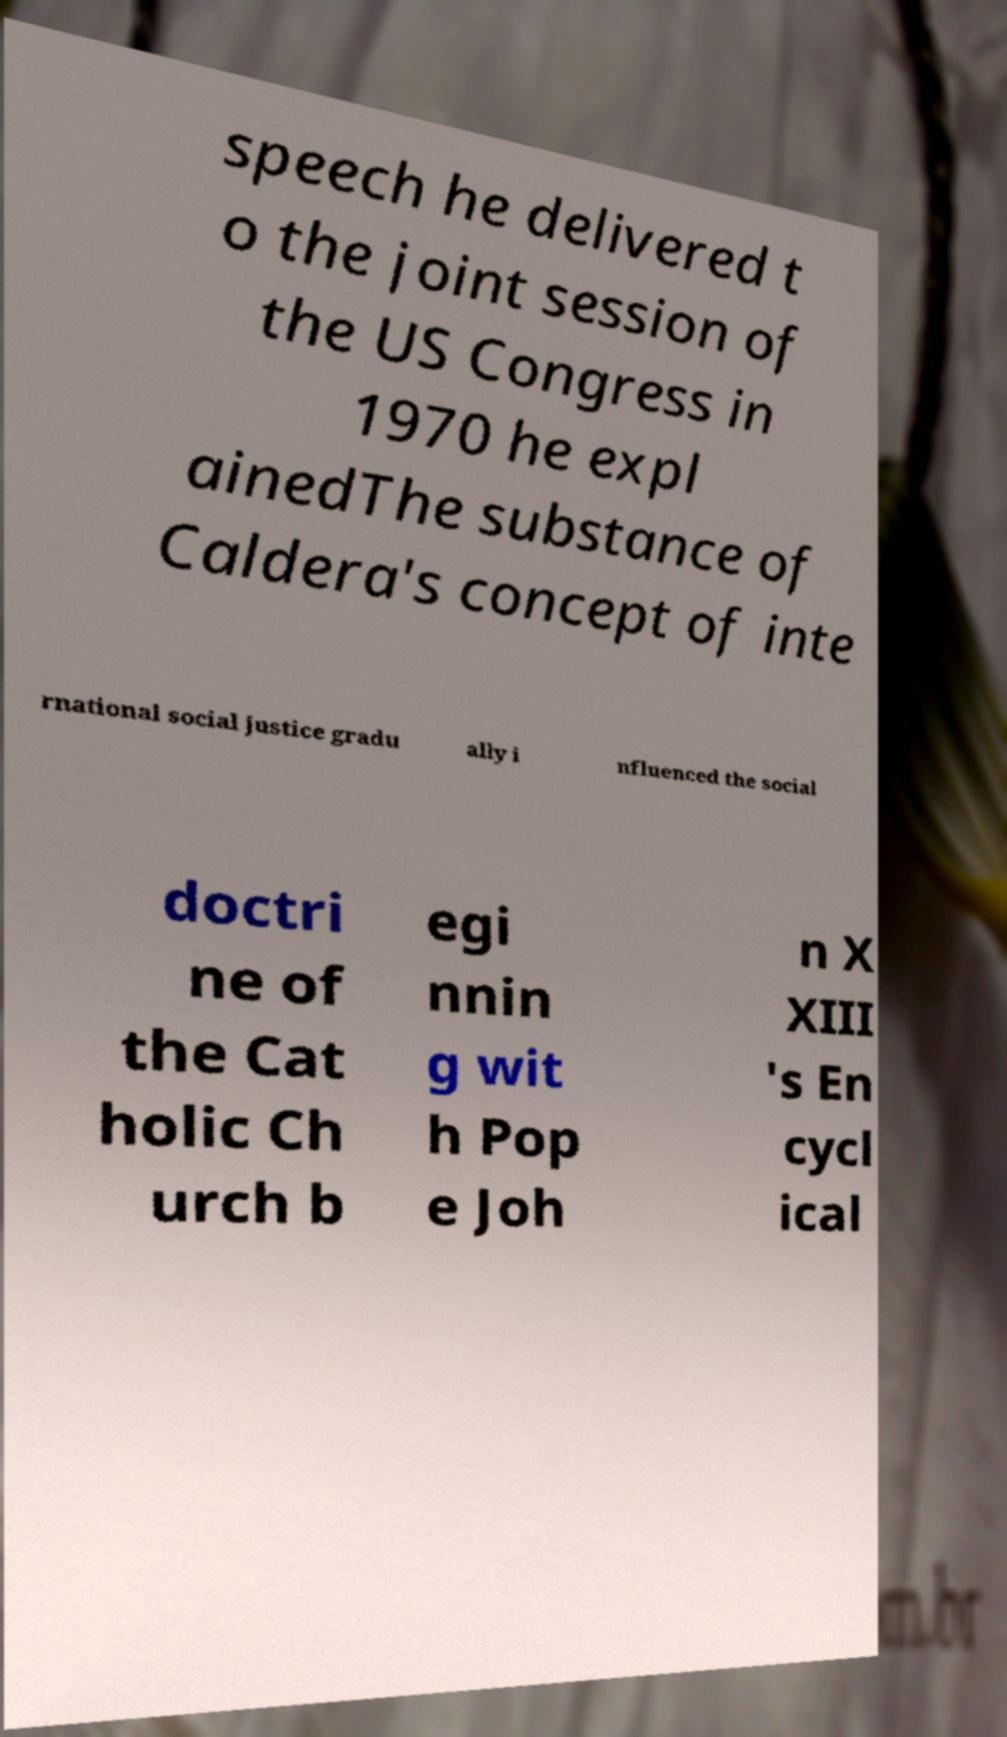There's text embedded in this image that I need extracted. Can you transcribe it verbatim? speech he delivered t o the joint session of the US Congress in 1970 he expl ainedThe substance of Caldera's concept of inte rnational social justice gradu ally i nfluenced the social doctri ne of the Cat holic Ch urch b egi nnin g wit h Pop e Joh n X XIII 's En cycl ical 